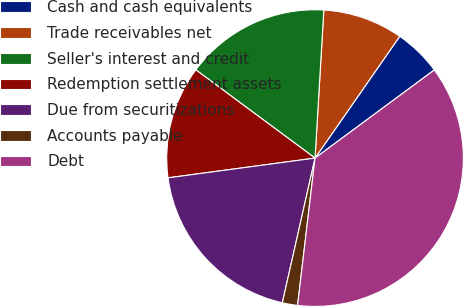<chart> <loc_0><loc_0><loc_500><loc_500><pie_chart><fcel>Cash and cash equivalents<fcel>Trade receivables net<fcel>Seller's interest and credit<fcel>Redemption settlement assets<fcel>Due from securitizations<fcel>Accounts payable<fcel>Debt<nl><fcel>5.2%<fcel>8.73%<fcel>15.8%<fcel>12.27%<fcel>19.34%<fcel>1.66%<fcel>37.01%<nl></chart> 